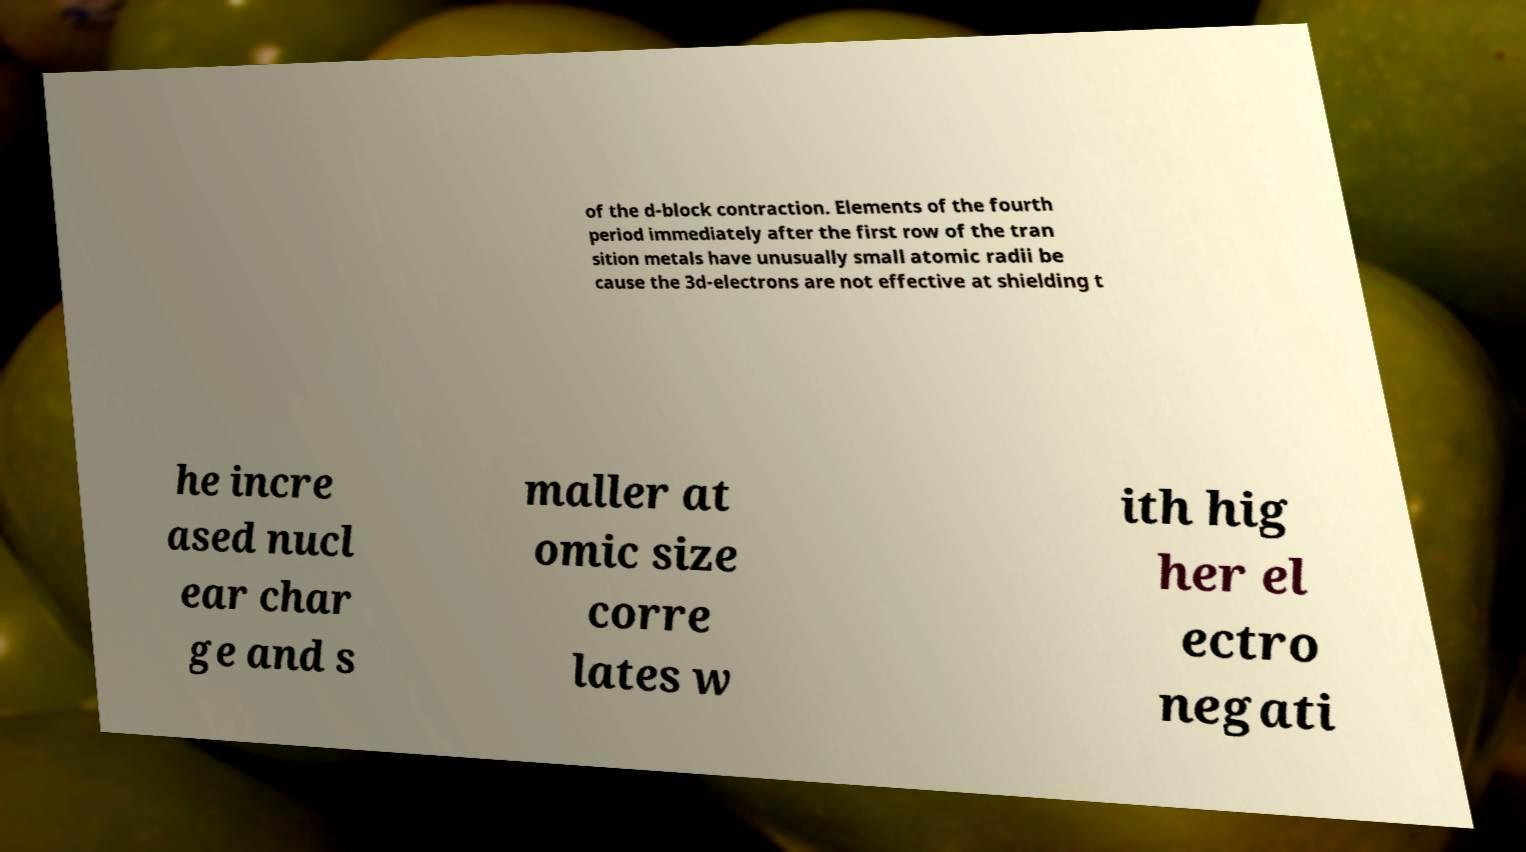Can you read and provide the text displayed in the image?This photo seems to have some interesting text. Can you extract and type it out for me? of the d-block contraction. Elements of the fourth period immediately after the first row of the tran sition metals have unusually small atomic radii be cause the 3d-electrons are not effective at shielding t he incre ased nucl ear char ge and s maller at omic size corre lates w ith hig her el ectro negati 